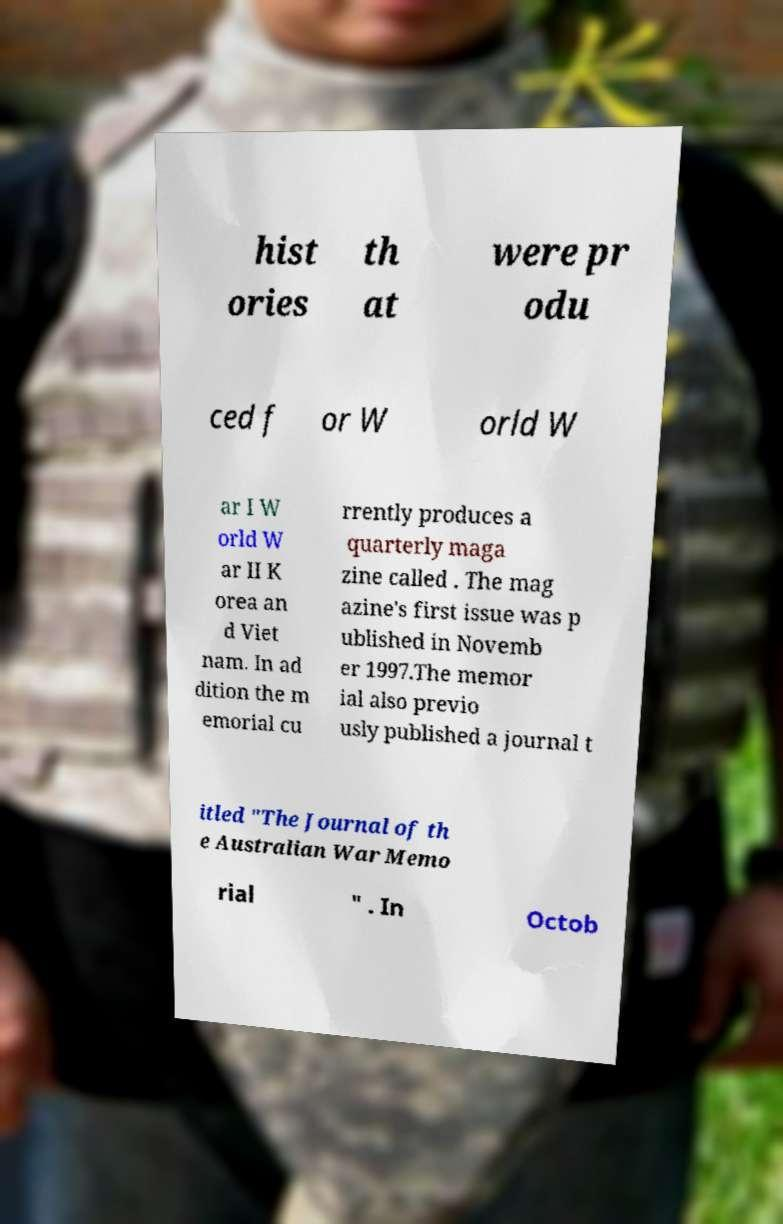Please identify and transcribe the text found in this image. hist ories th at were pr odu ced f or W orld W ar I W orld W ar II K orea an d Viet nam. In ad dition the m emorial cu rrently produces a quarterly maga zine called . The mag azine's first issue was p ublished in Novemb er 1997.The memor ial also previo usly published a journal t itled "The Journal of th e Australian War Memo rial " . In Octob 